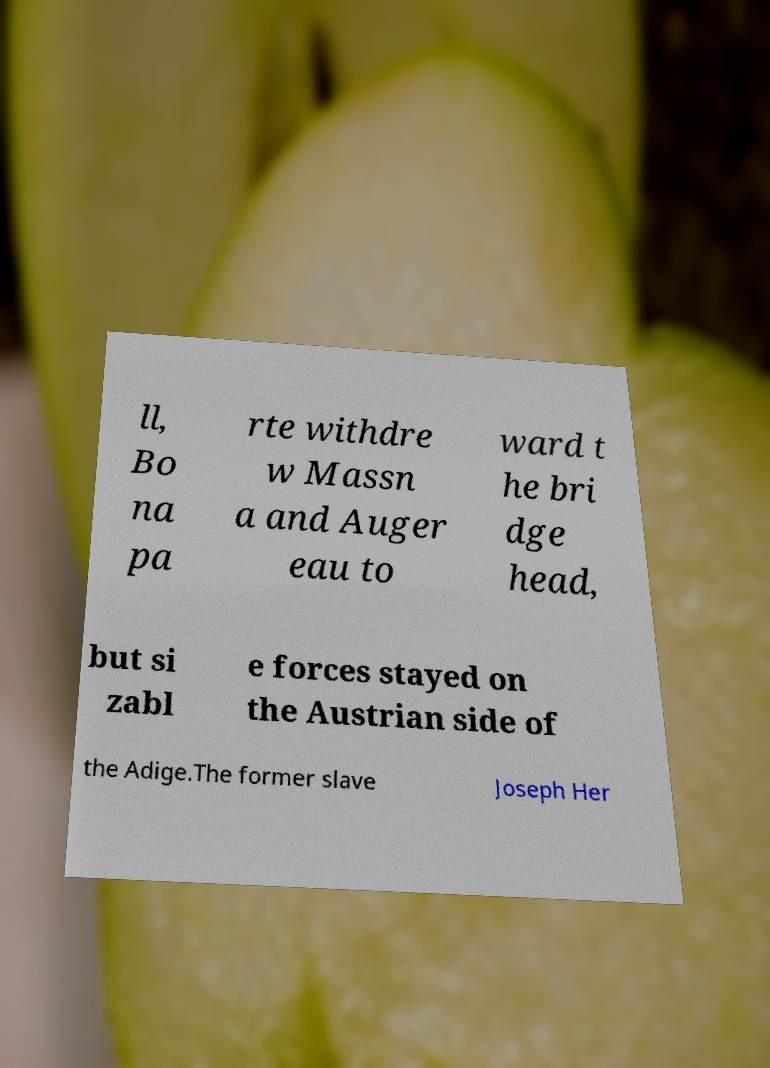I need the written content from this picture converted into text. Can you do that? ll, Bo na pa rte withdre w Massn a and Auger eau to ward t he bri dge head, but si zabl e forces stayed on the Austrian side of the Adige.The former slave Joseph Her 